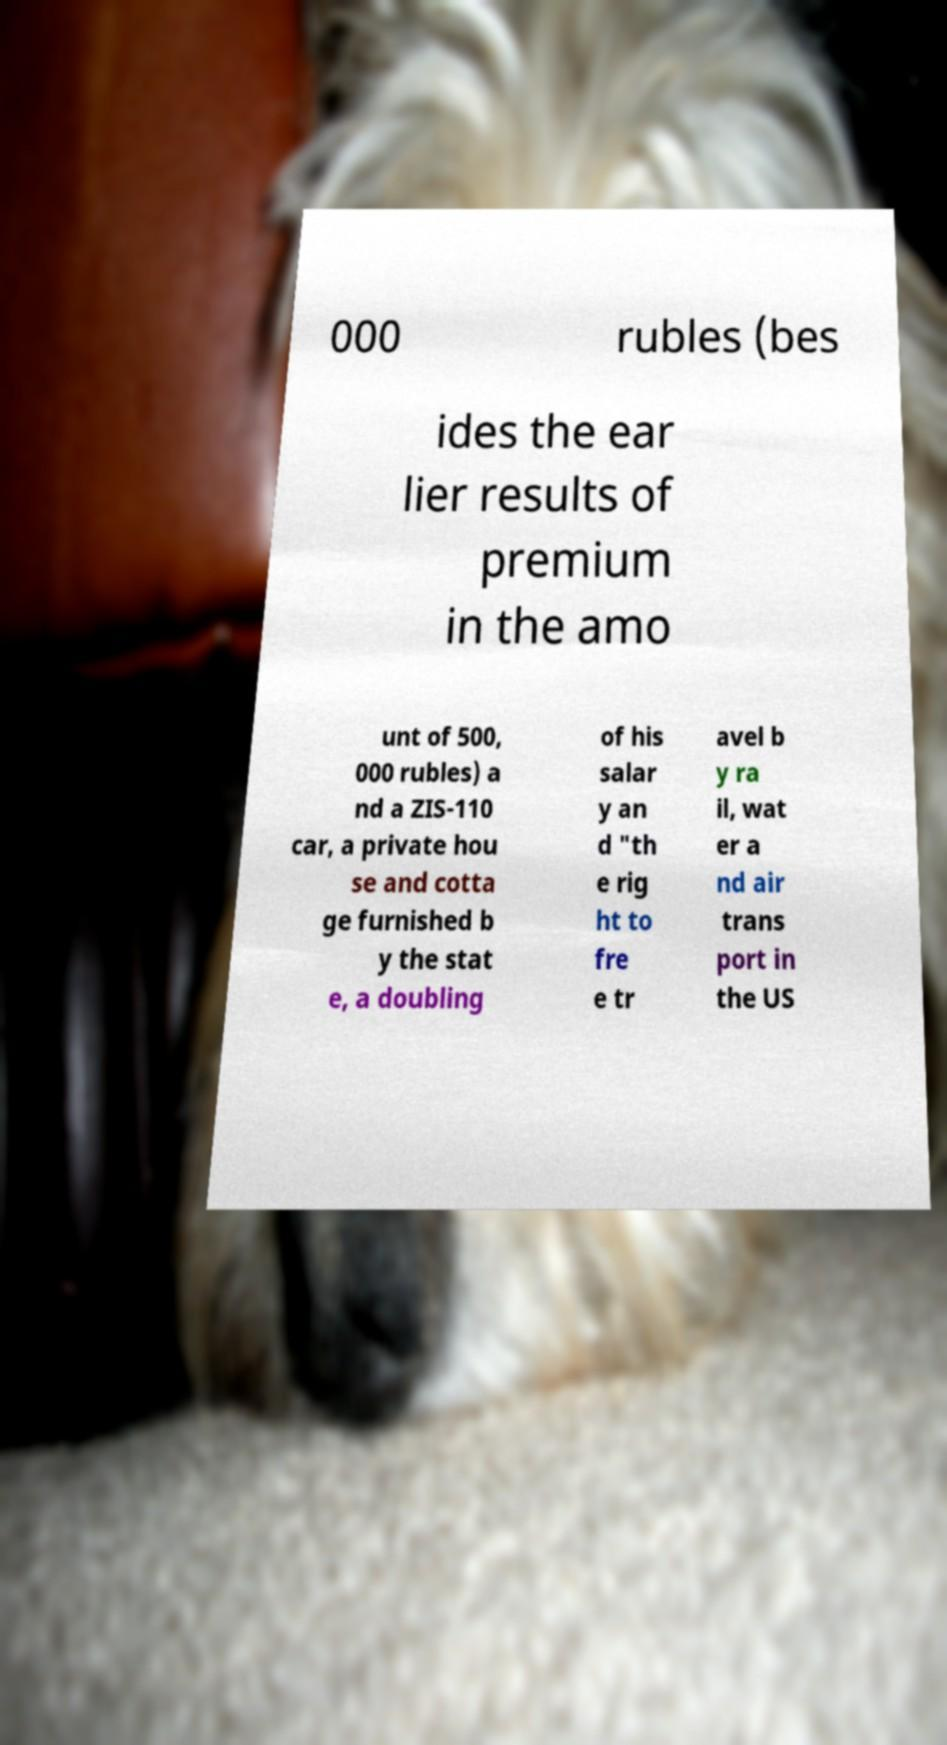Could you assist in decoding the text presented in this image and type it out clearly? 000 rubles (bes ides the ear lier results of premium in the amo unt of 500, 000 rubles) a nd a ZIS-110 car, a private hou se and cotta ge furnished b y the stat e, a doubling of his salar y an d "th e rig ht to fre e tr avel b y ra il, wat er a nd air trans port in the US 